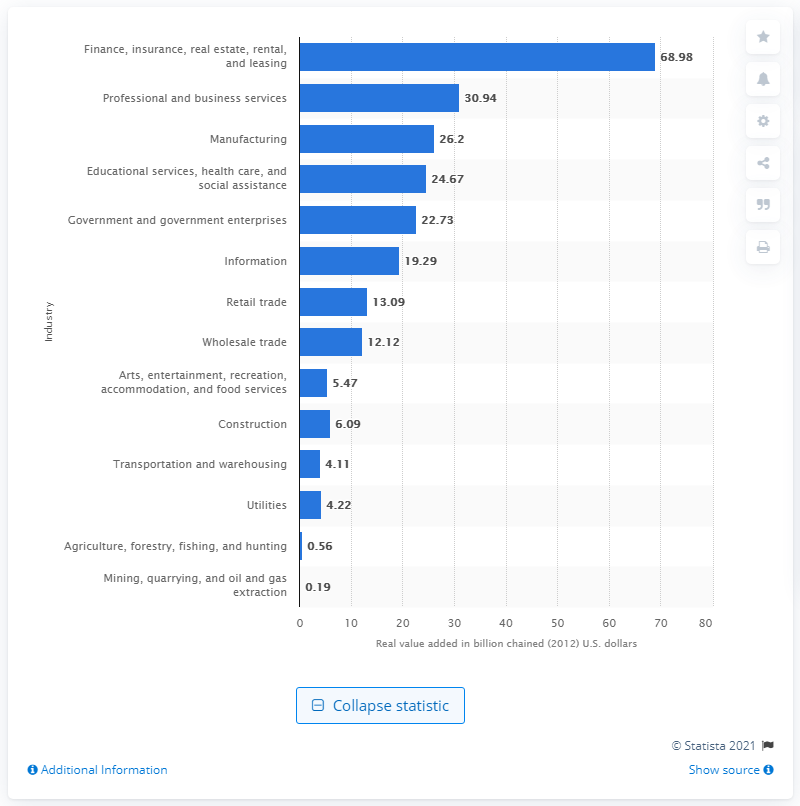Could you list the top three industries that contribute to Connecticut's GDP, including their contribution values? Certainly, the top three industries contributing to Connecticut's GDP are: 1. Finance, insurance, real estate, rental, and leasing with $68.98 billion, 2. Professional and business services with $30.94 billion, and 3. Manufacturing with $26.2 billion. 